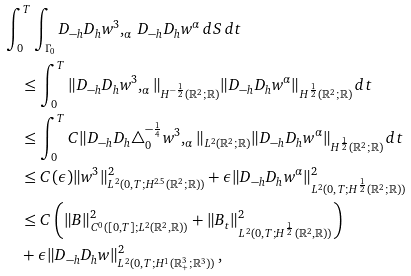<formula> <loc_0><loc_0><loc_500><loc_500>& \int _ { 0 } ^ { T } \int _ { \Gamma _ { 0 } } D _ { - h } D _ { h } w ^ { 3 } , _ { \alpha } \, D _ { - h } D _ { h } w ^ { \alpha } \, d S \, d t \\ & \quad \leq \int _ { 0 } ^ { T } \| D _ { - h } D _ { h } w ^ { 3 } , _ { \alpha } \| _ { H ^ { - \frac { 1 } { 2 } } ( { \mathbb { R } } ^ { 2 } ; { \mathbb { R } } ) } \| D _ { - h } D _ { h } w ^ { \alpha } \| _ { H ^ { \frac { 1 } { 2 } } ( { \mathbb { R } } ^ { 2 } ; { \mathbb { R } } ) } \, d t \\ & \quad \leq \int _ { 0 } ^ { T } C \| D _ { - h } D _ { h } \triangle _ { 0 } ^ { - \frac { 1 } { 4 } } w ^ { 3 } , _ { \alpha } \| _ { L ^ { 2 } ( { \mathbb { R } } ^ { 2 } ; { \mathbb { R } } ) } \| D _ { - h } D _ { h } w ^ { \alpha } \| _ { H ^ { \frac { 1 } { 2 } } ( { \mathbb { R } } ^ { 2 } ; { \mathbb { R } } ) } \, d t \\ & \quad \leq C ( \epsilon ) \| w ^ { 3 } \| ^ { 2 } _ { L ^ { 2 } ( 0 , T ; H ^ { 2 . 5 } ( { \mathbb { R } } ^ { 2 } ; { \mathbb { R } } ) ) } + \epsilon \| D _ { - h } D _ { h } w ^ { \alpha } \| ^ { 2 } _ { L ^ { 2 } ( 0 , T ; H ^ { \frac { 1 } { 2 } } ( { \mathbb { R } } ^ { 2 } ; { \mathbb { R } } ) ) } \\ & \quad \leq C \left ( \| B \| ^ { 2 } _ { C ^ { 0 } ( [ 0 , T ] ; L ^ { 2 } ( { \mathbb { R } } ^ { 2 } , { \mathbb { R } } ) ) } + \| B _ { t } \| ^ { 2 } _ { L ^ { 2 } ( 0 , T ; H ^ { \frac { 1 } { 2 } } ( { \mathbb { R } } ^ { 2 } , { \mathbb { R } } ) ) } \right ) \\ & \quad + \epsilon \| D _ { - h } D _ { h } w \| ^ { 2 } _ { L ^ { 2 } ( 0 , T ; H ^ { 1 } ( { \mathbb { R } } ^ { 3 } _ { + } ; { \mathbb { R } ^ { 3 } } ) ) } \, ,</formula> 